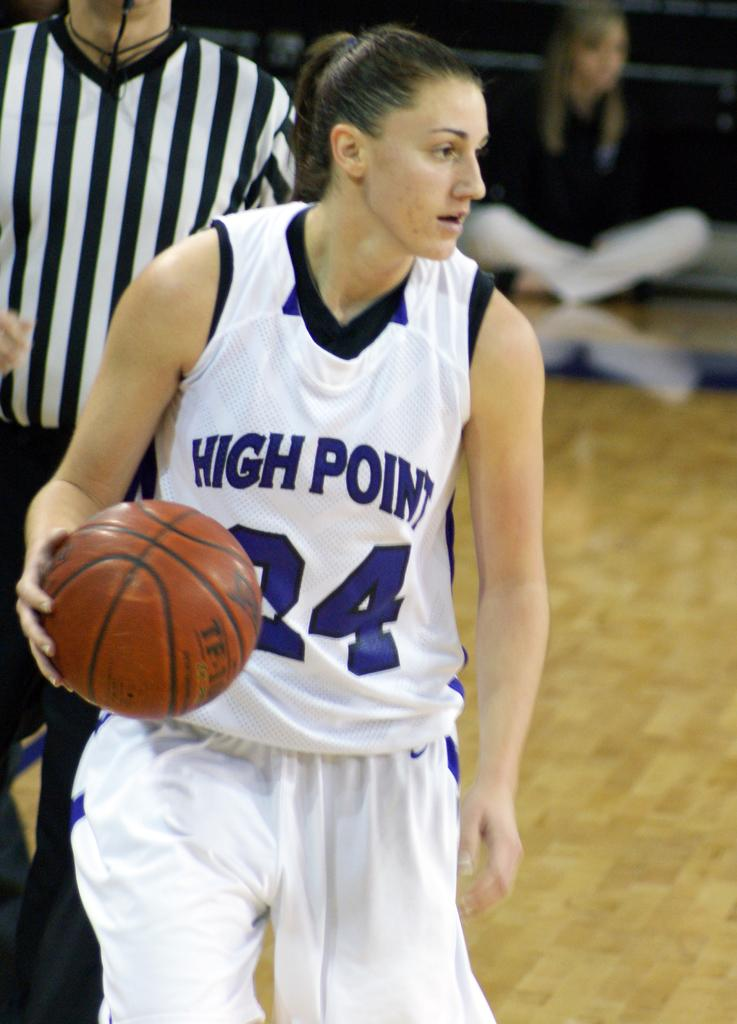Provide a one-sentence caption for the provided image. a women playing basketball with the uniform number 24. 